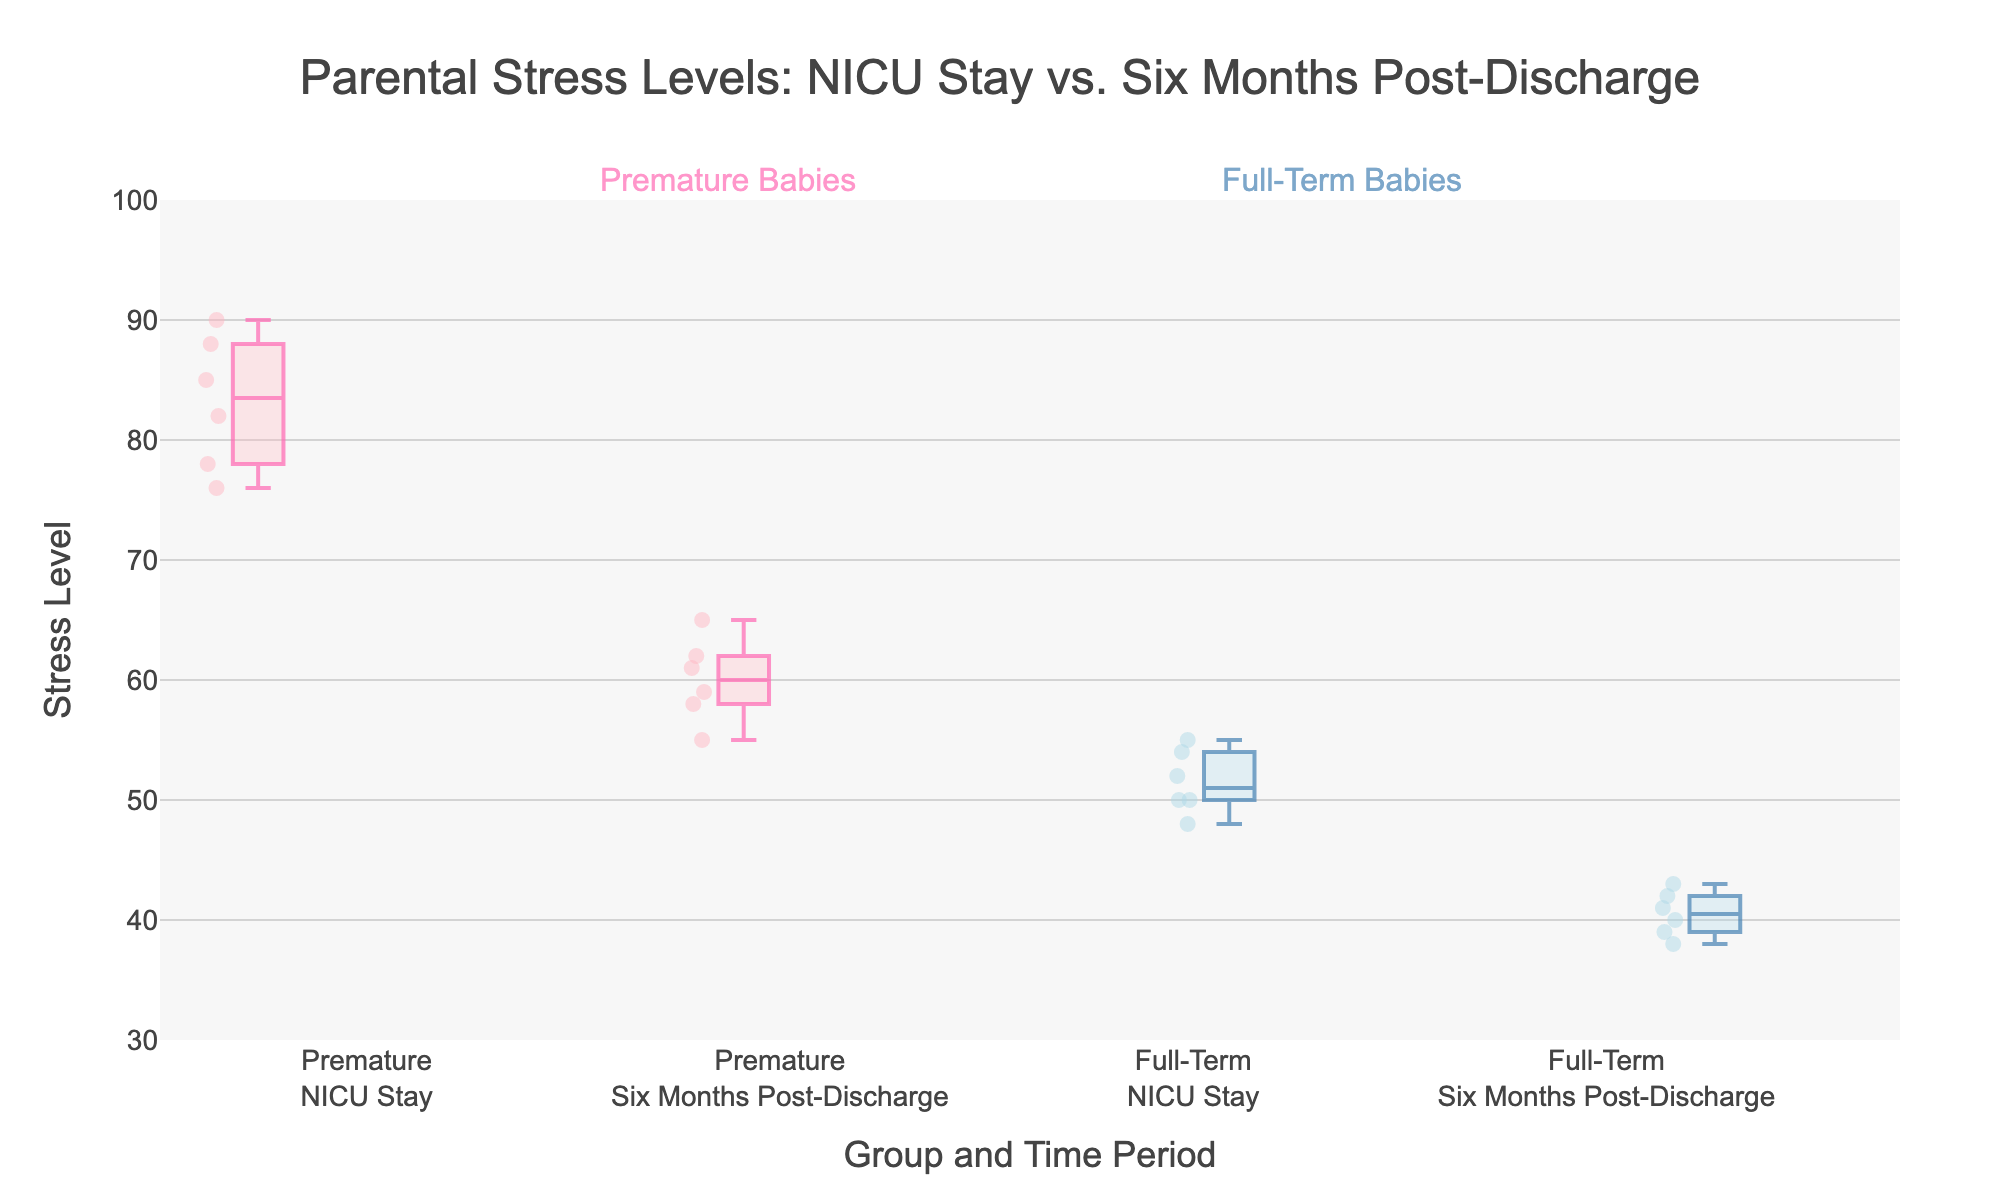What is the title of the plot? The title can be seen at the top of the figure. It is "Parental Stress Levels: NICU Stay vs. Six Months Post-Discharge".
Answer: Parental Stress Levels: NICU Stay vs. Six Months Post-Discharge What are the two groups compared in the plot? The two groups can be identified by the labels and colors of the boxes. They are "Premature" and "Full-Term".
Answer: Premature and Full-Term How many data points are there for the stress levels of premature babies during the NICU stay? Each box plot shows data points represented as scattered points. Counting these points for Premature during NICU Stay yields six data points.
Answer: 6 Which time period shows higher stress levels on average for premature babies? By comparing the median lines in both box plots for premature babies, it's evident that the NICU stay has a higher median stress level compared to six months post-discharge.
Answer: NICU stay Did the stress levels of full-term parents increase or decrease from NICU stay to six months post-discharge? By comparing the median lines and overall distribution, we see that the stress levels decreased for full-term parents from NICU stay to six months post-discharge.
Answer: Decrease What is the median stress level for full-term parents six months post-discharge? To determine the median, look at the line inside the box of "Full-Term<br>Six Months Post-Discharge". The median line indicates the median value, which is around 40-41.
Answer: Around 40-41 Compare the variability in stress levels of premature parents during NICU stay and six months post-discharge. Variability can be assessed by the range and spread of the box plots. The box representing NICU Stay for premature babies is more spread out, indicating higher variability than the one for six months post-discharge.
Answer: Higher during NICU stay What is the interquartile range (IQR) of stress levels for premature parents during NICU stay? The IQR is the range between the first quartile (Q1, bottom of the box) and the third quartile (Q3, top of the box). For NICU stay, the values look roughly like Q1 = 76 and Q3 = 88, so IQR = 88 - 76 = 12.
Answer: 12 How do the median stress levels compare between premature and full-term parents during the NICU stay? The median stress level for premature parents during the NICU stay (inside the first box) is higher than that for full-term parents during NICU stay (inside the third box).
Answer: Higher for premature parents What is the general trend in stress levels from NICU stay to six months post-discharge for both groups? By looking at both pairs of box plots for each group, stress levels generally decrease from NICU stay to six months post-discharge for both premature and full-term groups.
Answer: Decrease 